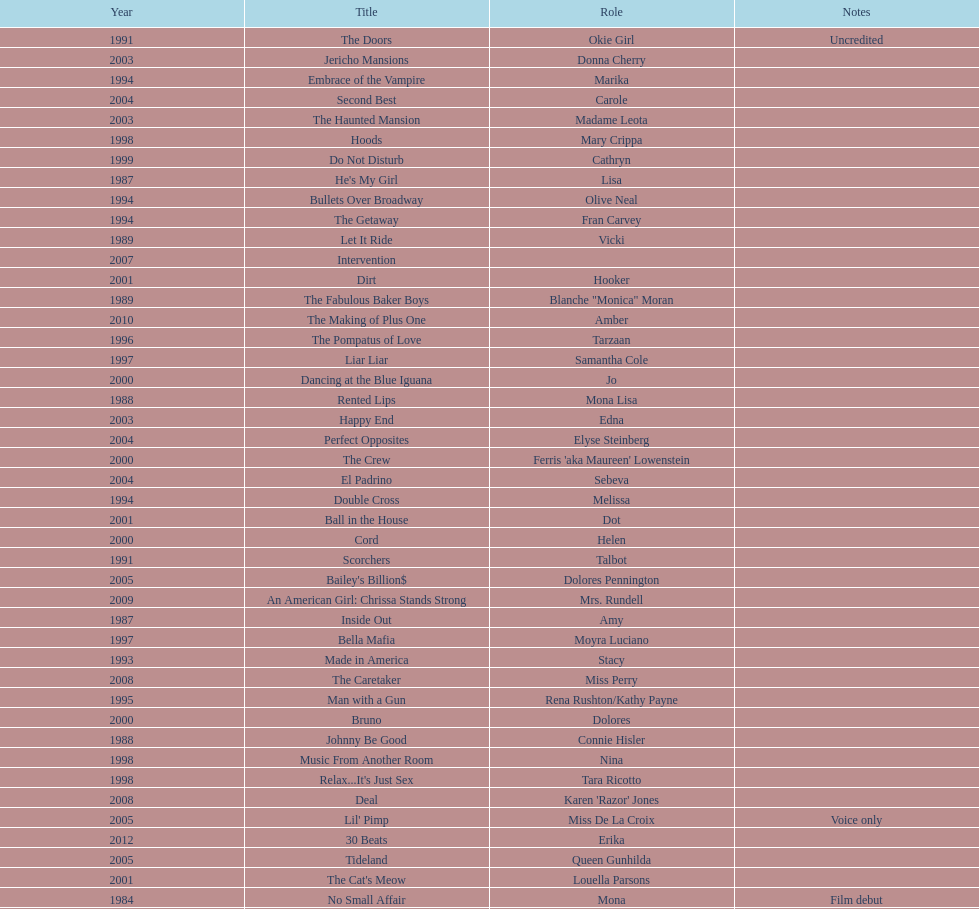How many rolls did jennifer tilly play in the 1980s? 11. 